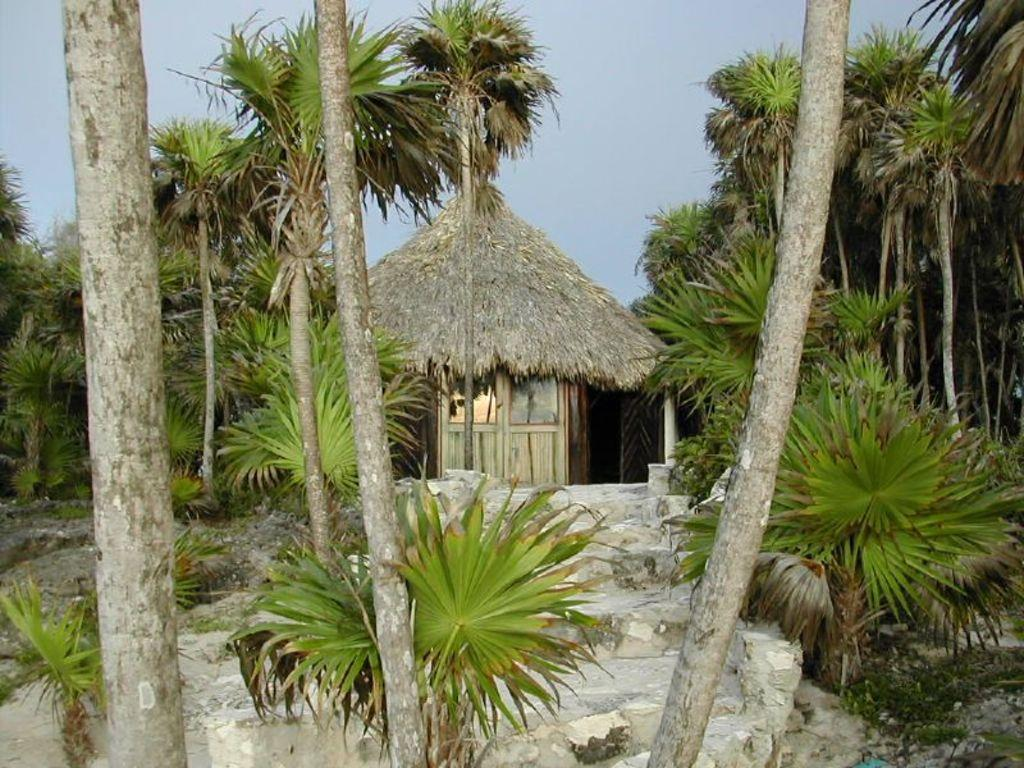What type of vegetation can be seen in the image? There are trees in the image. What type of structure is present in the image? There is a hut in the image. Does the hut have any specific features? Yes, the hut has a door. What is visible in the sky in the image? Clouds are visible in the sky. What type of brass instrument is being played in the image? There is no brass instrument present in the image; it features trees, a hut, and clouds. What form does the hut take in the image? The hut is a simple, rectangular structure with a door. 